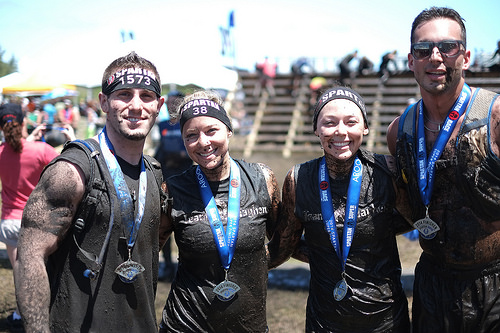<image>
Is the man next to the lady? Yes. The man is positioned adjacent to the lady, located nearby in the same general area. 